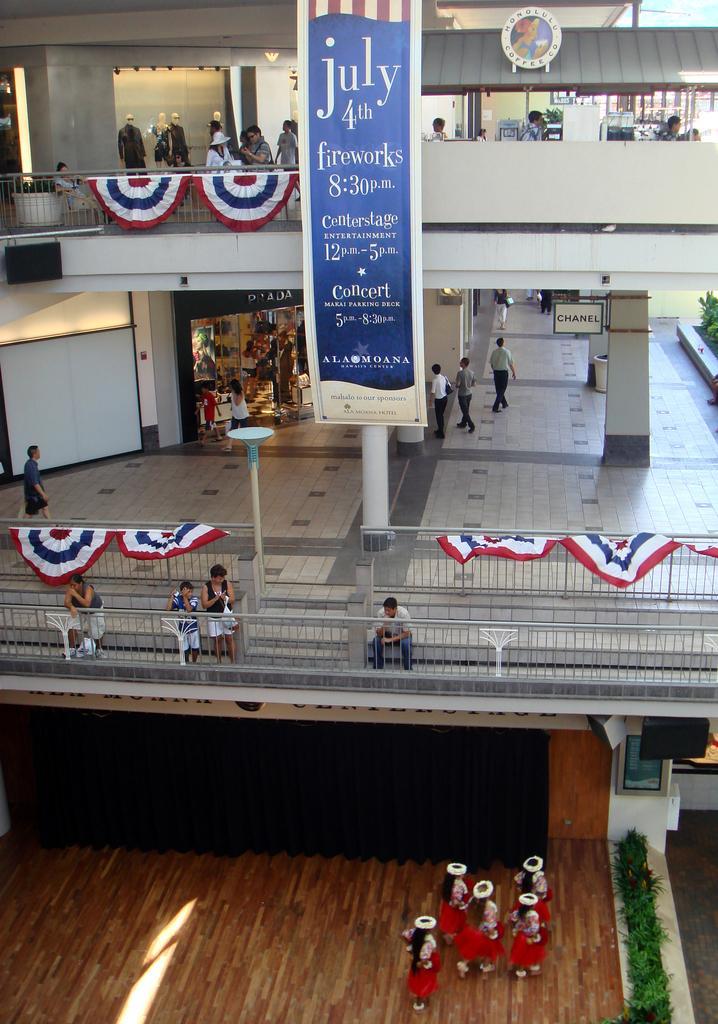Could you give a brief overview of what you see in this image? In this picture we can observe some people behind the railing. There is a blue and cream color poster. There are some people standing on the floor, wearing red color dresses. We can observe some pillars. There are mannequins on the left side. On the right side there are plants. 